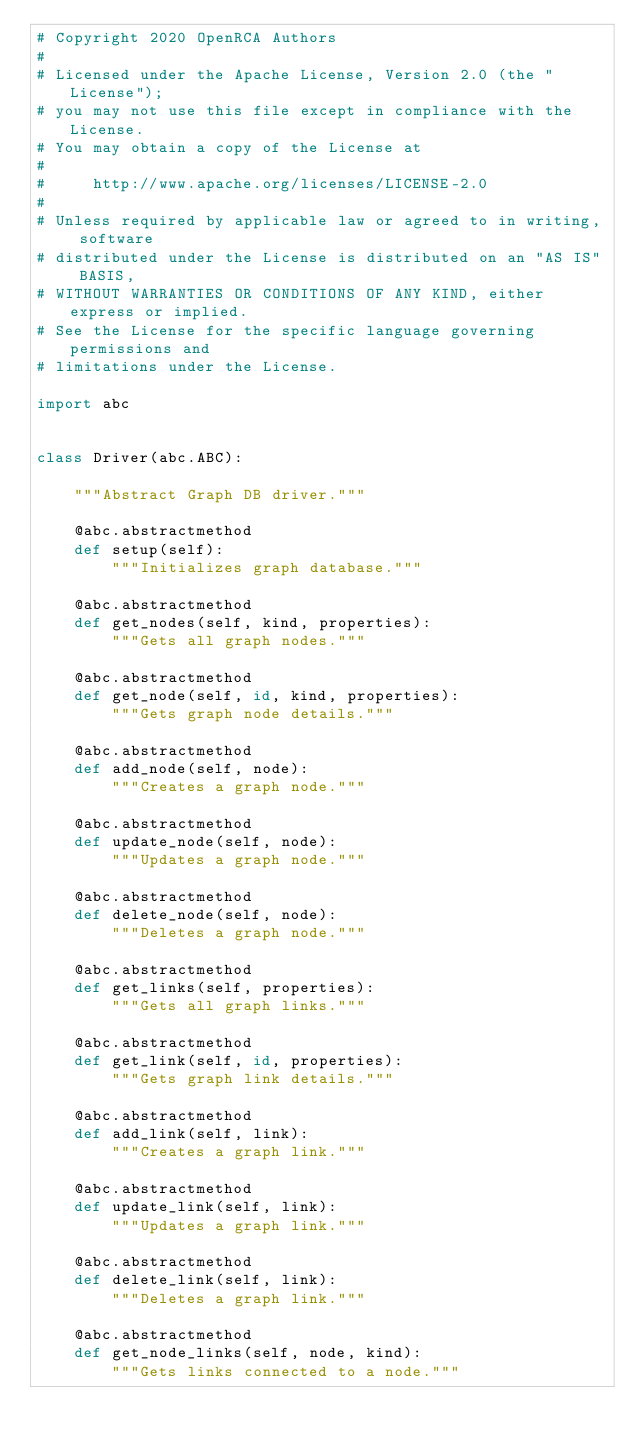<code> <loc_0><loc_0><loc_500><loc_500><_Python_># Copyright 2020 OpenRCA Authors
#
# Licensed under the Apache License, Version 2.0 (the "License");
# you may not use this file except in compliance with the License.
# You may obtain a copy of the License at
#
#     http://www.apache.org/licenses/LICENSE-2.0
#
# Unless required by applicable law or agreed to in writing, software
# distributed under the License is distributed on an "AS IS" BASIS,
# WITHOUT WARRANTIES OR CONDITIONS OF ANY KIND, either express or implied.
# See the License for the specific language governing permissions and
# limitations under the License.

import abc


class Driver(abc.ABC):

    """Abstract Graph DB driver."""

    @abc.abstractmethod
    def setup(self):
        """Initializes graph database."""

    @abc.abstractmethod
    def get_nodes(self, kind, properties):
        """Gets all graph nodes."""

    @abc.abstractmethod
    def get_node(self, id, kind, properties):
        """Gets graph node details."""

    @abc.abstractmethod
    def add_node(self, node):
        """Creates a graph node."""

    @abc.abstractmethod
    def update_node(self, node):
        """Updates a graph node."""

    @abc.abstractmethod
    def delete_node(self, node):
        """Deletes a graph node."""

    @abc.abstractmethod
    def get_links(self, properties):
        """Gets all graph links."""

    @abc.abstractmethod
    def get_link(self, id, properties):
        """Gets graph link details."""

    @abc.abstractmethod
    def add_link(self, link):
        """Creates a graph link."""

    @abc.abstractmethod
    def update_link(self, link):
        """Updates a graph link."""

    @abc.abstractmethod
    def delete_link(self, link):
        """Deletes a graph link."""

    @abc.abstractmethod
    def get_node_links(self, node, kind):
        """Gets links connected to a node."""
</code> 